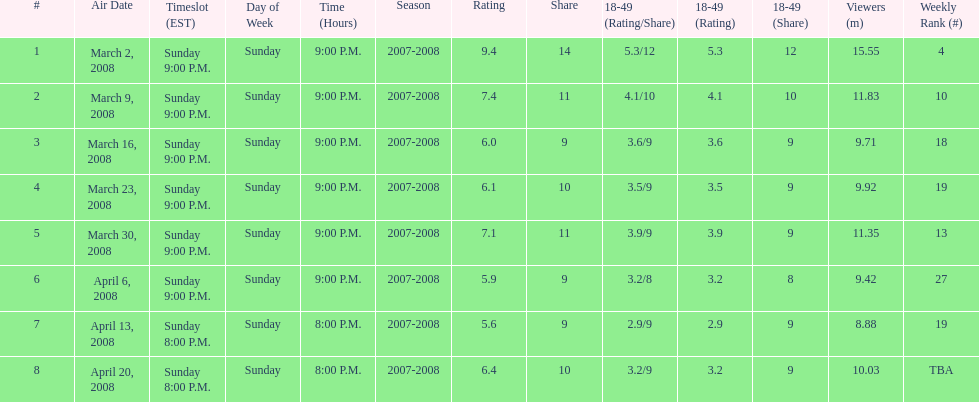How many shows had at least 10 million viewers? 4. 